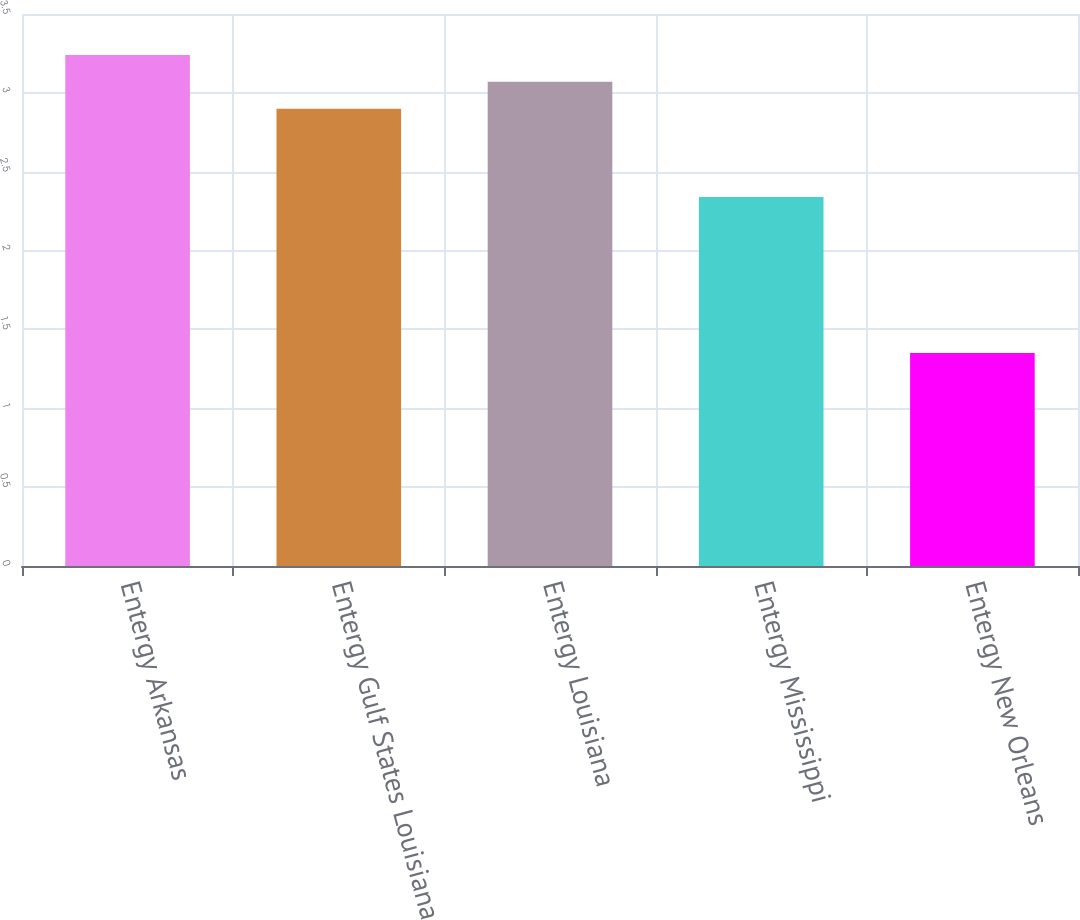Convert chart. <chart><loc_0><loc_0><loc_500><loc_500><bar_chart><fcel>Entergy Arkansas<fcel>Entergy Gulf States Louisiana<fcel>Entergy Louisiana<fcel>Entergy Mississippi<fcel>Entergy New Orleans<nl><fcel>3.24<fcel>2.9<fcel>3.07<fcel>2.34<fcel>1.35<nl></chart> 